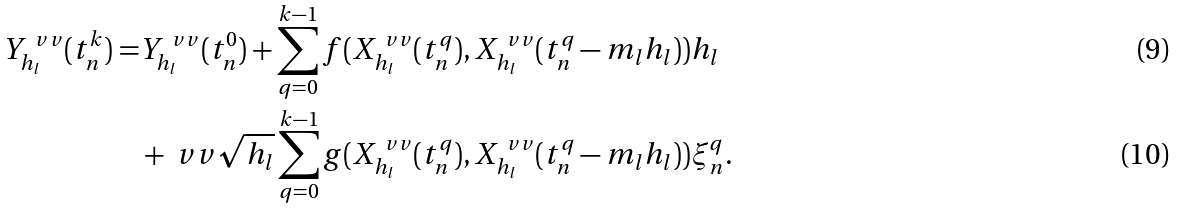<formula> <loc_0><loc_0><loc_500><loc_500>Y ^ { \ v v } _ { h _ { l } } ( t _ { n } ^ { k } ) = & Y ^ { \ v v } _ { h _ { l } } ( t _ { n } ^ { 0 } ) + \sum _ { q = 0 } ^ { k - 1 } f ( X ^ { \ v v } _ { h _ { l } } ( t _ { n } ^ { q } ) , X ^ { \ v v } _ { h _ { l } } ( t _ { n } ^ { q } - m _ { l } h _ { l } ) ) h _ { l } \\ & + \ v v \sqrt { h _ { l } } \sum _ { q = 0 } ^ { k - 1 } g ( X ^ { \ v v } _ { h _ { l } } ( t _ { n } ^ { q } ) , X ^ { \ v v } _ { h _ { l } } ( t _ { n } ^ { q } - m _ { l } h _ { l } ) ) \xi _ { n } ^ { q } .</formula> 